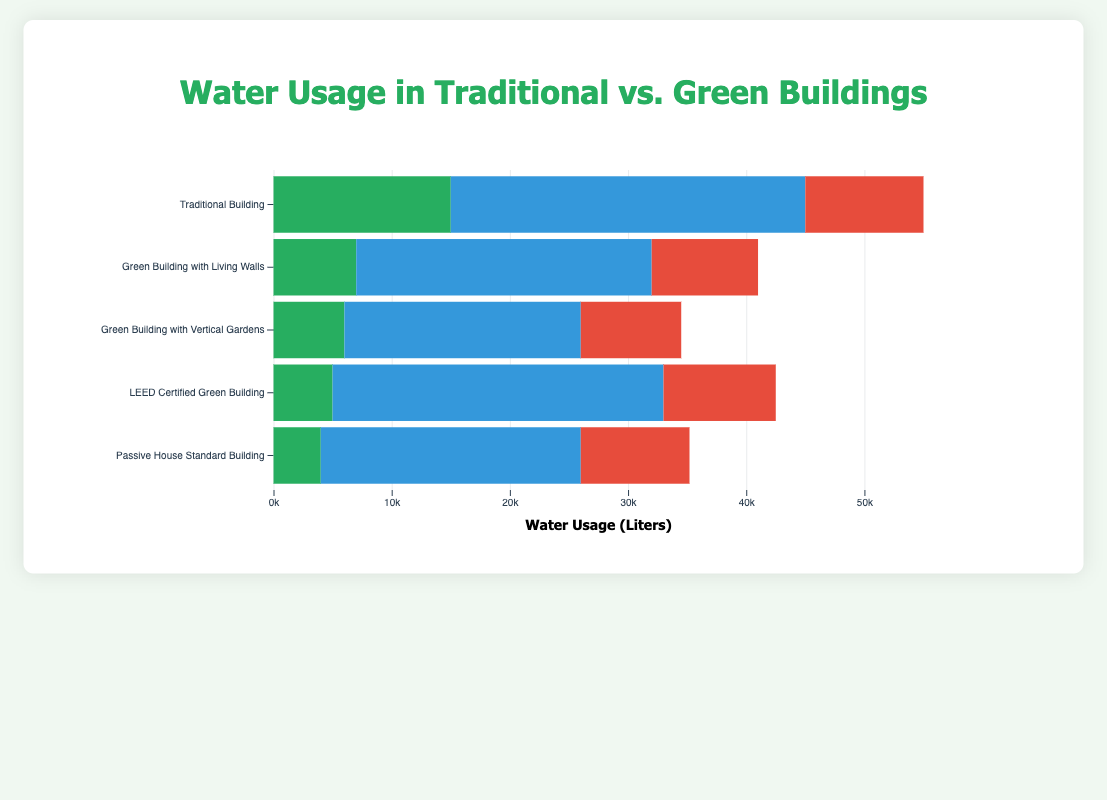Which building type has the lowest total water usage for Irrigation, Sanitation, and Drinking combined? To find the building type with the lowest total water usage, sum the water usage for Irrigation, Sanitation, and Drinking for each building type. The totals are: Traditional Building: 55000 L, Green Building with Living Walls: 41000 L, Green Building with Vertical Gardens: 34500 L, LEED Certified Green Building: 42500 L, Passive House Standard Building: 35200 L. The Green Building with Vertical Gardens has the lowest total.
Answer: Green Building with Vertical Gardens How does the water usage for irrigation in Traditional Building compare to Passive House Standard Building? Compare the water usage for irrigation in both buildings. Traditional Building uses 15000 L for irrigation, while Passive House Standard Building uses 4000 L. Traditional Building uses more water for irrigation than Passive House Standard Building.
Answer: Traditional Building uses more What is the difference in water usage for sanitation between the Traditional Building and the LEED Certified Green Building? Subtract the sanitation water usage of LEED Certified Green Building (28000 L) from that of Traditional Building (30000 L): 30000 - 28000 = 2000 L.
Answer: 2000 L Which category of water usage shows the greatest reduction when comparing Traditional Building to Green Building with Living Walls? Calculate the reductions in each category: Irrigation: 15000 (Traditional) - 7000 (Green with Living Walls) = 8000 L, Sanitation: 30000 - 25000 = 5000 L, Drinking: 10000 - 9000 = 1000 L. The greatest reduction is in Irrigation.
Answer: Irrigation If you aim to reduce overall water usage by 20% in a Traditional Building, what should the total water usage be? The current total water usage for a Traditional Building is 55000 L. To achieve a 20% reduction: 55000 * 0.20 = 11000 L, so the new total should be 55000 - 11000 = 44000 L.
Answer: 44000 L What is the average water usage for drinking across all building types? To find the average water usage for drinking, sum the water usage for drinking for all buildings and divide by the number of buildings: (10000 + 9000 + 8500 + 9500 + 9200) / 5 = 46200 / 5 = 9240 L.
Answer: 9240 L How much more water does the Traditional Building use for drinking compared to the Green Building with Vertical Gardens? Subtract the drinking water usage of the Green Building with Vertical Gardens (8500 L) from that of the Traditional Building (10000 L): 10000 - 8500 = 1500 L.
Answer: 1500 L Which building has the highest water usage for sanitation, and what is that value? Identify the highest sanitation water usage value among all buildings. The values are: Traditional Building: 30000 L, Green Building with Living Walls: 25000 L, Green Building with Vertical Gardens: 20000 L, LEED Certified Green Building: 28000 L, Passive House Standard Building: 22000 L. The Traditional Building has the highest value at 30000 L.
Answer: Traditional Building, 30000 L Comparing the water usage for irrigation between Green Building with Living Walls and LEED Certified Green Building, what is the percentage decrease or increase? Calculate the percentage decrease: (7000 - 5000) / 7000 * 100 = 2000 / 7000 * 100 ≈ 28.57% decrease.
Answer: 28.57% decrease What is the total water usage across all building types for the category of drinking? Sum the drinking water usage for all buildings: 10000 (Traditional) + 9000 (Living Walls) + 8500 (Vertical Gardens) + 9500 (LEED) + 9200 (Passive) = 46200 L.
Answer: 46200 L 